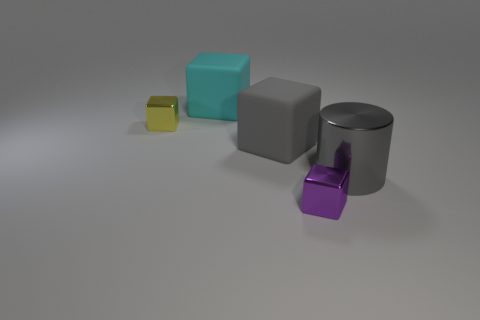Subtract 1 blocks. How many blocks are left? 3 Subtract all green blocks. Subtract all red cylinders. How many blocks are left? 4 Add 1 big cylinders. How many objects exist? 6 Subtract all blocks. How many objects are left? 1 Add 3 large cyan matte things. How many large cyan matte things exist? 4 Subtract 0 green balls. How many objects are left? 5 Subtract all gray cylinders. Subtract all yellow metal objects. How many objects are left? 3 Add 4 large rubber blocks. How many large rubber blocks are left? 6 